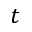<formula> <loc_0><loc_0><loc_500><loc_500>t</formula> 